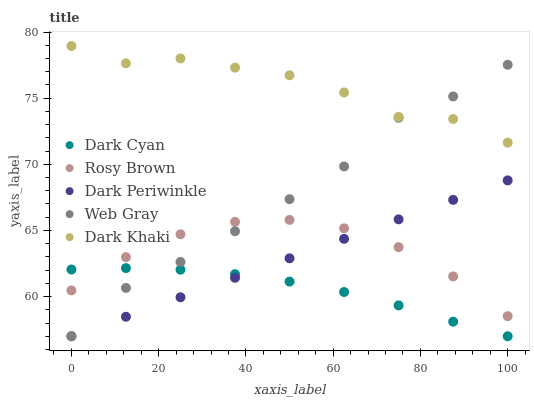Does Dark Cyan have the minimum area under the curve?
Answer yes or no. Yes. Does Dark Khaki have the maximum area under the curve?
Answer yes or no. Yes. Does Rosy Brown have the minimum area under the curve?
Answer yes or no. No. Does Rosy Brown have the maximum area under the curve?
Answer yes or no. No. Is Dark Periwinkle the smoothest?
Answer yes or no. Yes. Is Dark Khaki the roughest?
Answer yes or no. Yes. Is Rosy Brown the smoothest?
Answer yes or no. No. Is Rosy Brown the roughest?
Answer yes or no. No. Does Dark Cyan have the lowest value?
Answer yes or no. Yes. Does Rosy Brown have the lowest value?
Answer yes or no. No. Does Dark Khaki have the highest value?
Answer yes or no. Yes. Does Rosy Brown have the highest value?
Answer yes or no. No. Is Rosy Brown less than Dark Khaki?
Answer yes or no. Yes. Is Dark Khaki greater than Rosy Brown?
Answer yes or no. Yes. Does Web Gray intersect Dark Periwinkle?
Answer yes or no. Yes. Is Web Gray less than Dark Periwinkle?
Answer yes or no. No. Is Web Gray greater than Dark Periwinkle?
Answer yes or no. No. Does Rosy Brown intersect Dark Khaki?
Answer yes or no. No. 